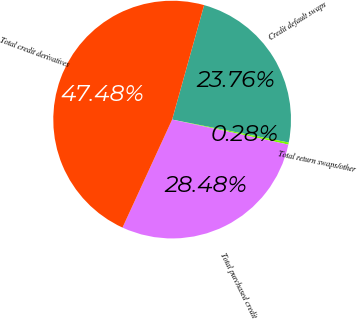<chart> <loc_0><loc_0><loc_500><loc_500><pie_chart><fcel>Credit default swaps<fcel>Total return swaps/other<fcel>Total purchased credit<fcel>Total credit derivatives<nl><fcel>23.76%<fcel>0.28%<fcel>28.48%<fcel>47.48%<nl></chart> 